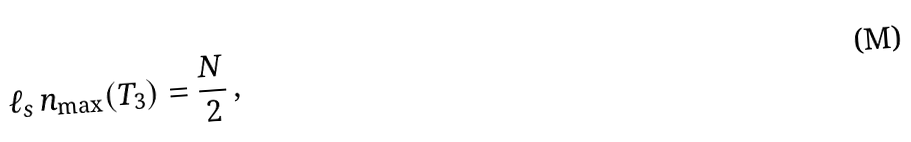Convert formula to latex. <formula><loc_0><loc_0><loc_500><loc_500>\ell _ { s } \, n _ { \max } ( T _ { 3 } ) = \frac { N } { 2 } \, ,</formula> 